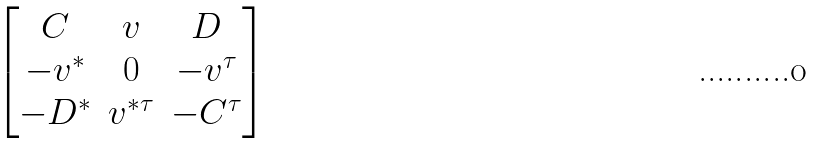Convert formula to latex. <formula><loc_0><loc_0><loc_500><loc_500>\begin{bmatrix} C & v & D \\ - v ^ { * } & 0 & - v ^ { \tau } \\ - D ^ { * } & v ^ { * \tau } & - C ^ { \tau } \end{bmatrix}</formula> 